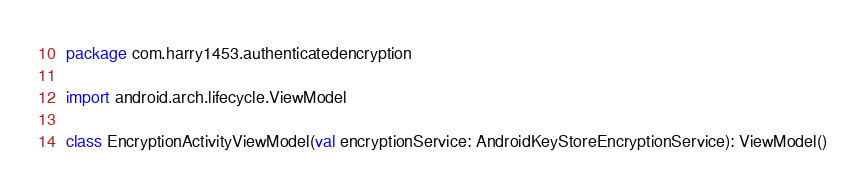Convert code to text. <code><loc_0><loc_0><loc_500><loc_500><_Kotlin_>package com.harry1453.authenticatedencryption

import android.arch.lifecycle.ViewModel

class EncryptionActivityViewModel(val encryptionService: AndroidKeyStoreEncryptionService): ViewModel()</code> 